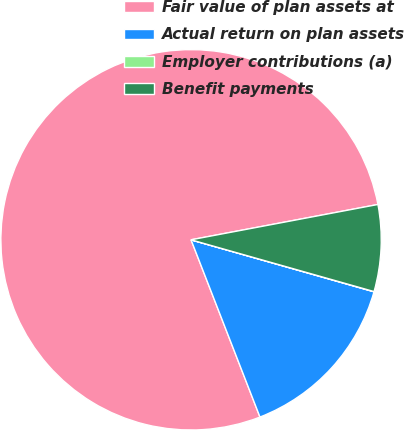Convert chart. <chart><loc_0><loc_0><loc_500><loc_500><pie_chart><fcel>Fair value of plan assets at<fcel>Actual return on plan assets<fcel>Employer contributions (a)<fcel>Benefit payments<nl><fcel>77.93%<fcel>14.69%<fcel>0.02%<fcel>7.36%<nl></chart> 